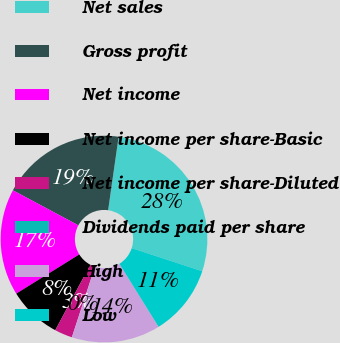Convert chart. <chart><loc_0><loc_0><loc_500><loc_500><pie_chart><fcel>Net sales<fcel>Gross profit<fcel>Net income<fcel>Net income per share-Basic<fcel>Net income per share-Diluted<fcel>Dividends paid per share<fcel>High<fcel>Low<nl><fcel>27.78%<fcel>19.44%<fcel>16.67%<fcel>8.33%<fcel>2.78%<fcel>0.0%<fcel>13.89%<fcel>11.11%<nl></chart> 